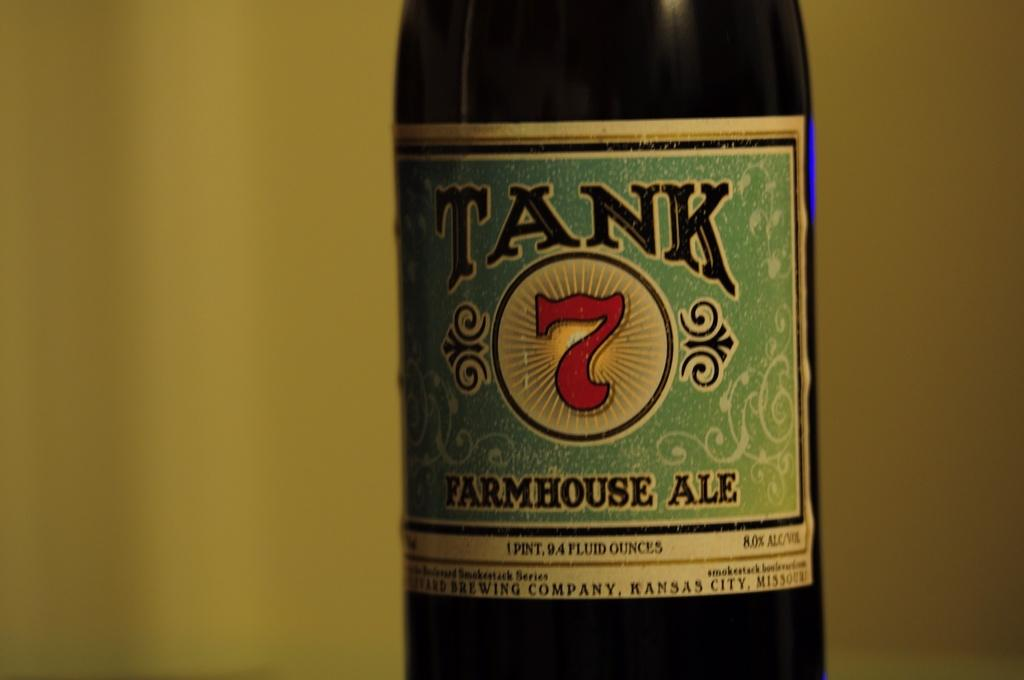What object can be seen in the image? There is a bottle in the image. What is written on the bottle? There is text written on the bottle. Can you see a jelly tree engine in the image? No, there is no jelly tree engine present in the image. 